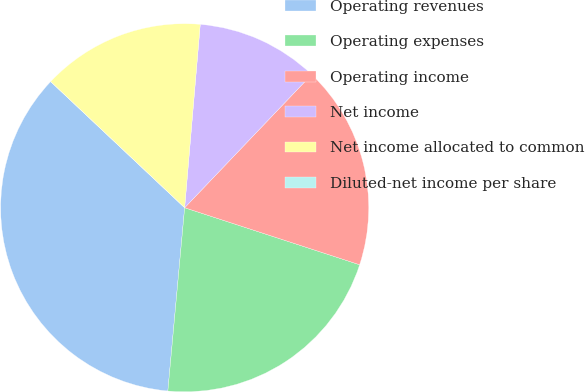Convert chart. <chart><loc_0><loc_0><loc_500><loc_500><pie_chart><fcel>Operating revenues<fcel>Operating expenses<fcel>Operating income<fcel>Net income<fcel>Net income allocated to common<fcel>Diluted-net income per share<nl><fcel>35.56%<fcel>21.44%<fcel>17.89%<fcel>10.77%<fcel>14.33%<fcel>0.0%<nl></chart> 